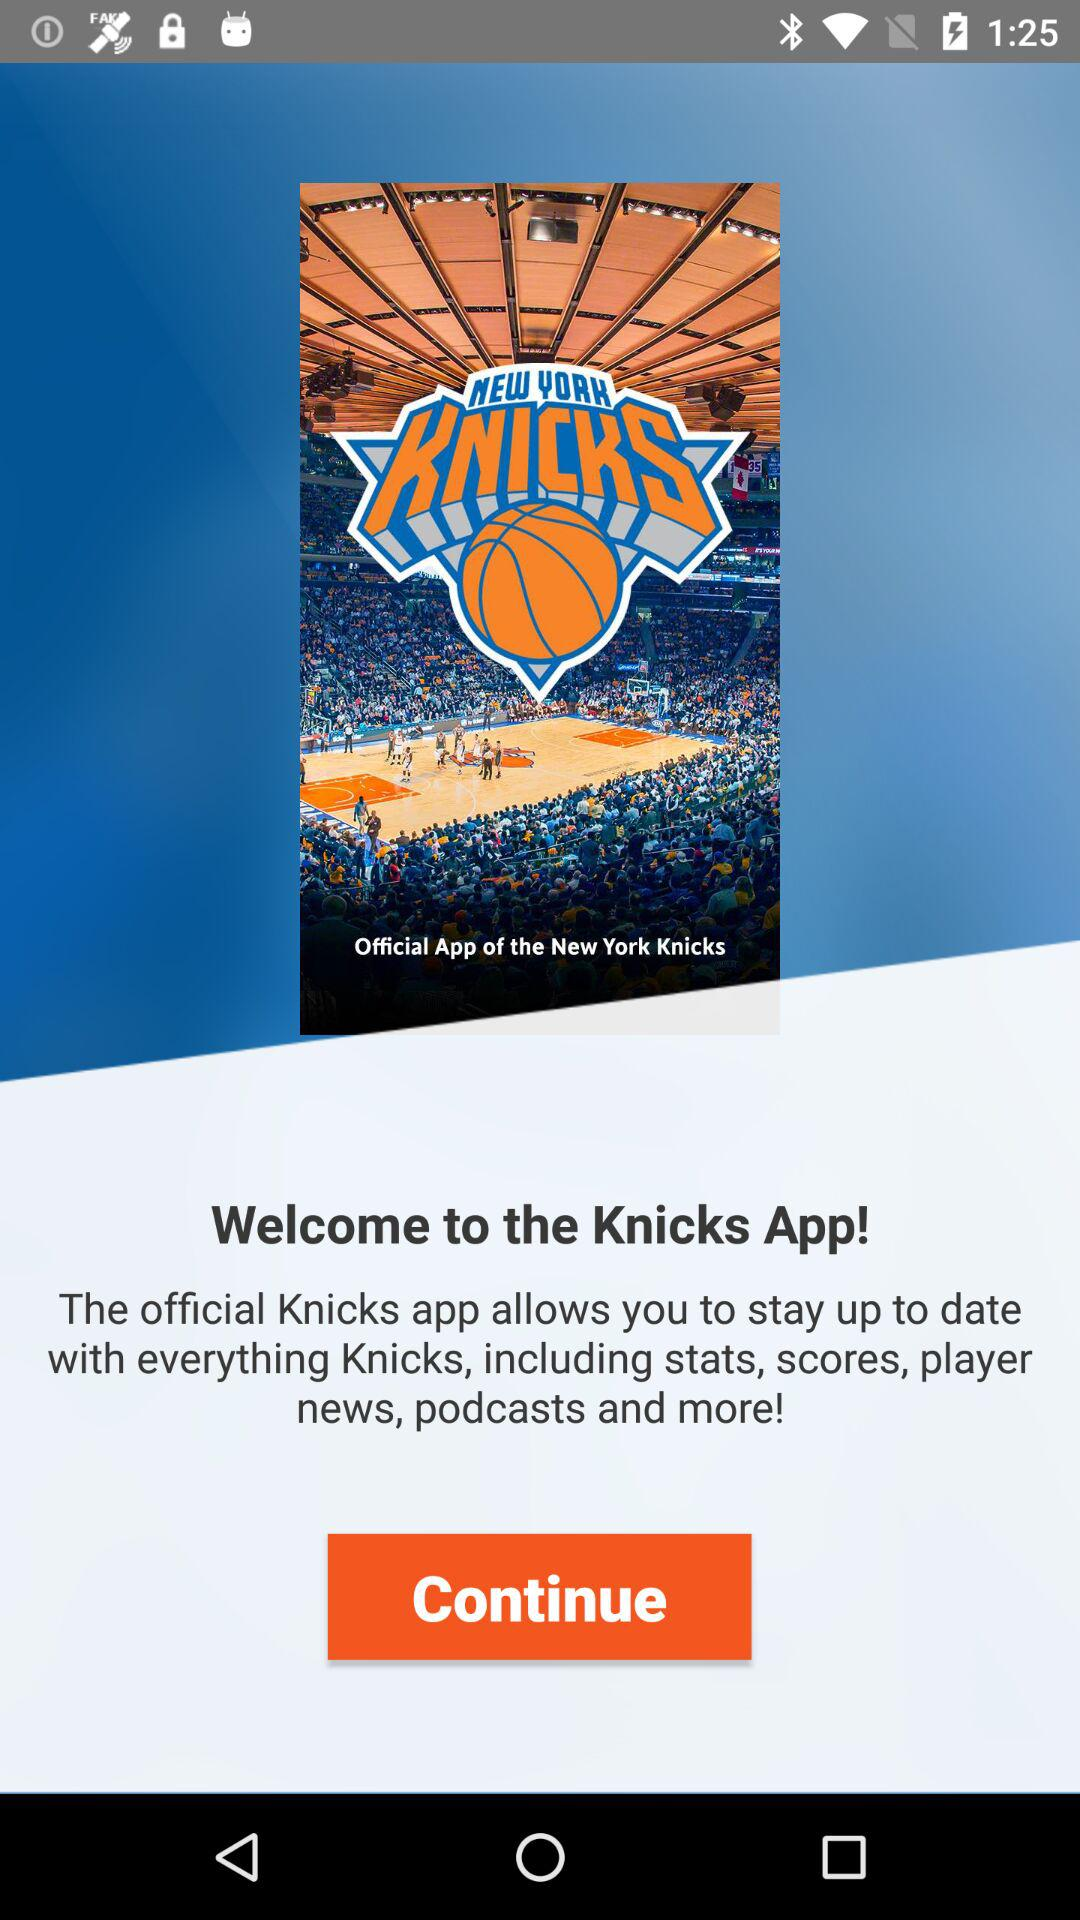What is the name of the application? The name of the application is "Knicks". 